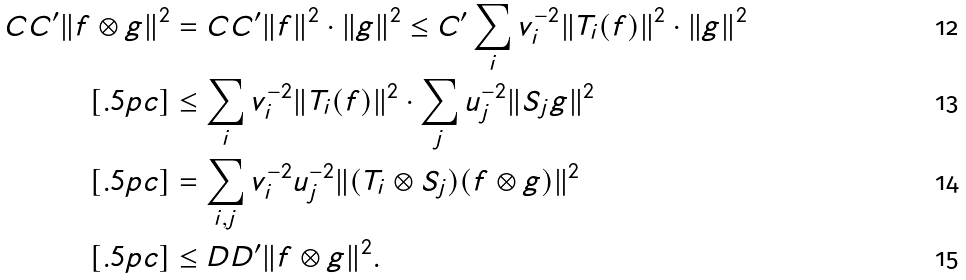<formula> <loc_0><loc_0><loc_500><loc_500>C C ^ { \prime } \| f \otimes g \| ^ { 2 } & = C C ^ { \prime } \| f \| ^ { 2 } \cdot \| g \| ^ { 2 } \leq C ^ { \prime } \sum _ { i } v _ { i } ^ { - 2 } \| T _ { i } ( f ) \| ^ { 2 } \cdot \| g \| ^ { 2 } \\ [ . 5 p c ] & \leq \sum _ { i } v _ { i } ^ { - 2 } \| T _ { i } ( f ) \| ^ { 2 } \cdot \sum _ { j } u _ { j } ^ { - 2 } \| S _ { j } g \| ^ { 2 } \\ [ . 5 p c ] & = \sum _ { i , j } v _ { i } ^ { - 2 } u _ { j } ^ { - 2 } \| ( T _ { i } \otimes S _ { j } ) ( f \otimes g ) \| ^ { 2 } \\ [ . 5 p c ] & \leq D D ^ { \prime } \| f \otimes g \| ^ { 2 } .</formula> 